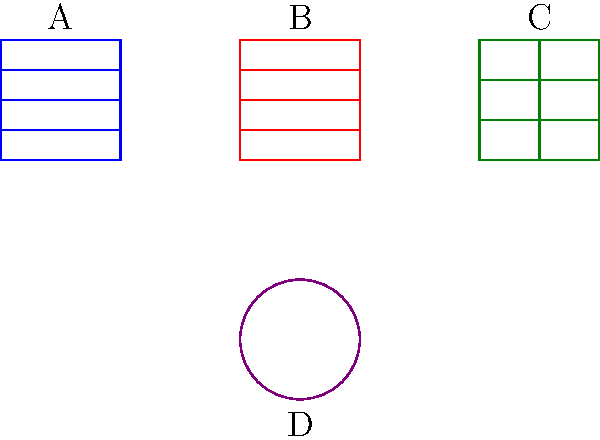In the context of Python data structures, which visual representation corresponds to an immutable, ordered collection of elements? To answer this question, let's analyze each visual representation and its corresponding Python data structure:

1. Structure A (top-left):
   - Rectangular shape with horizontal divisions
   - Represents a list in Python
   - Mutable and ordered collection of elements

2. Structure B (top-middle):
   - Rectangular shape with horizontal divisions
   - Similar to a list, but with a different color
   - Represents a tuple in Python
   - Immutable and ordered collection of elements

3. Structure C (top-right):
   - Rectangular shape with both horizontal and vertical divisions
   - Represents a dictionary in Python
   - Mutable and unordered collection of key-value pairs

4. Structure D (bottom):
   - Circular shape
   - Represents a set in Python
   - Mutable and unordered collection of unique elements

The question asks for an immutable, ordered collection of elements. Among these data structures, only the tuple (Structure B) satisfies both criteria:
- Immutable: Once created, its elements cannot be changed
- Ordered: Elements maintain their order and can be accessed by index

Therefore, the correct answer is the visual representation labeled B, which corresponds to a tuple in Python.
Answer: B 